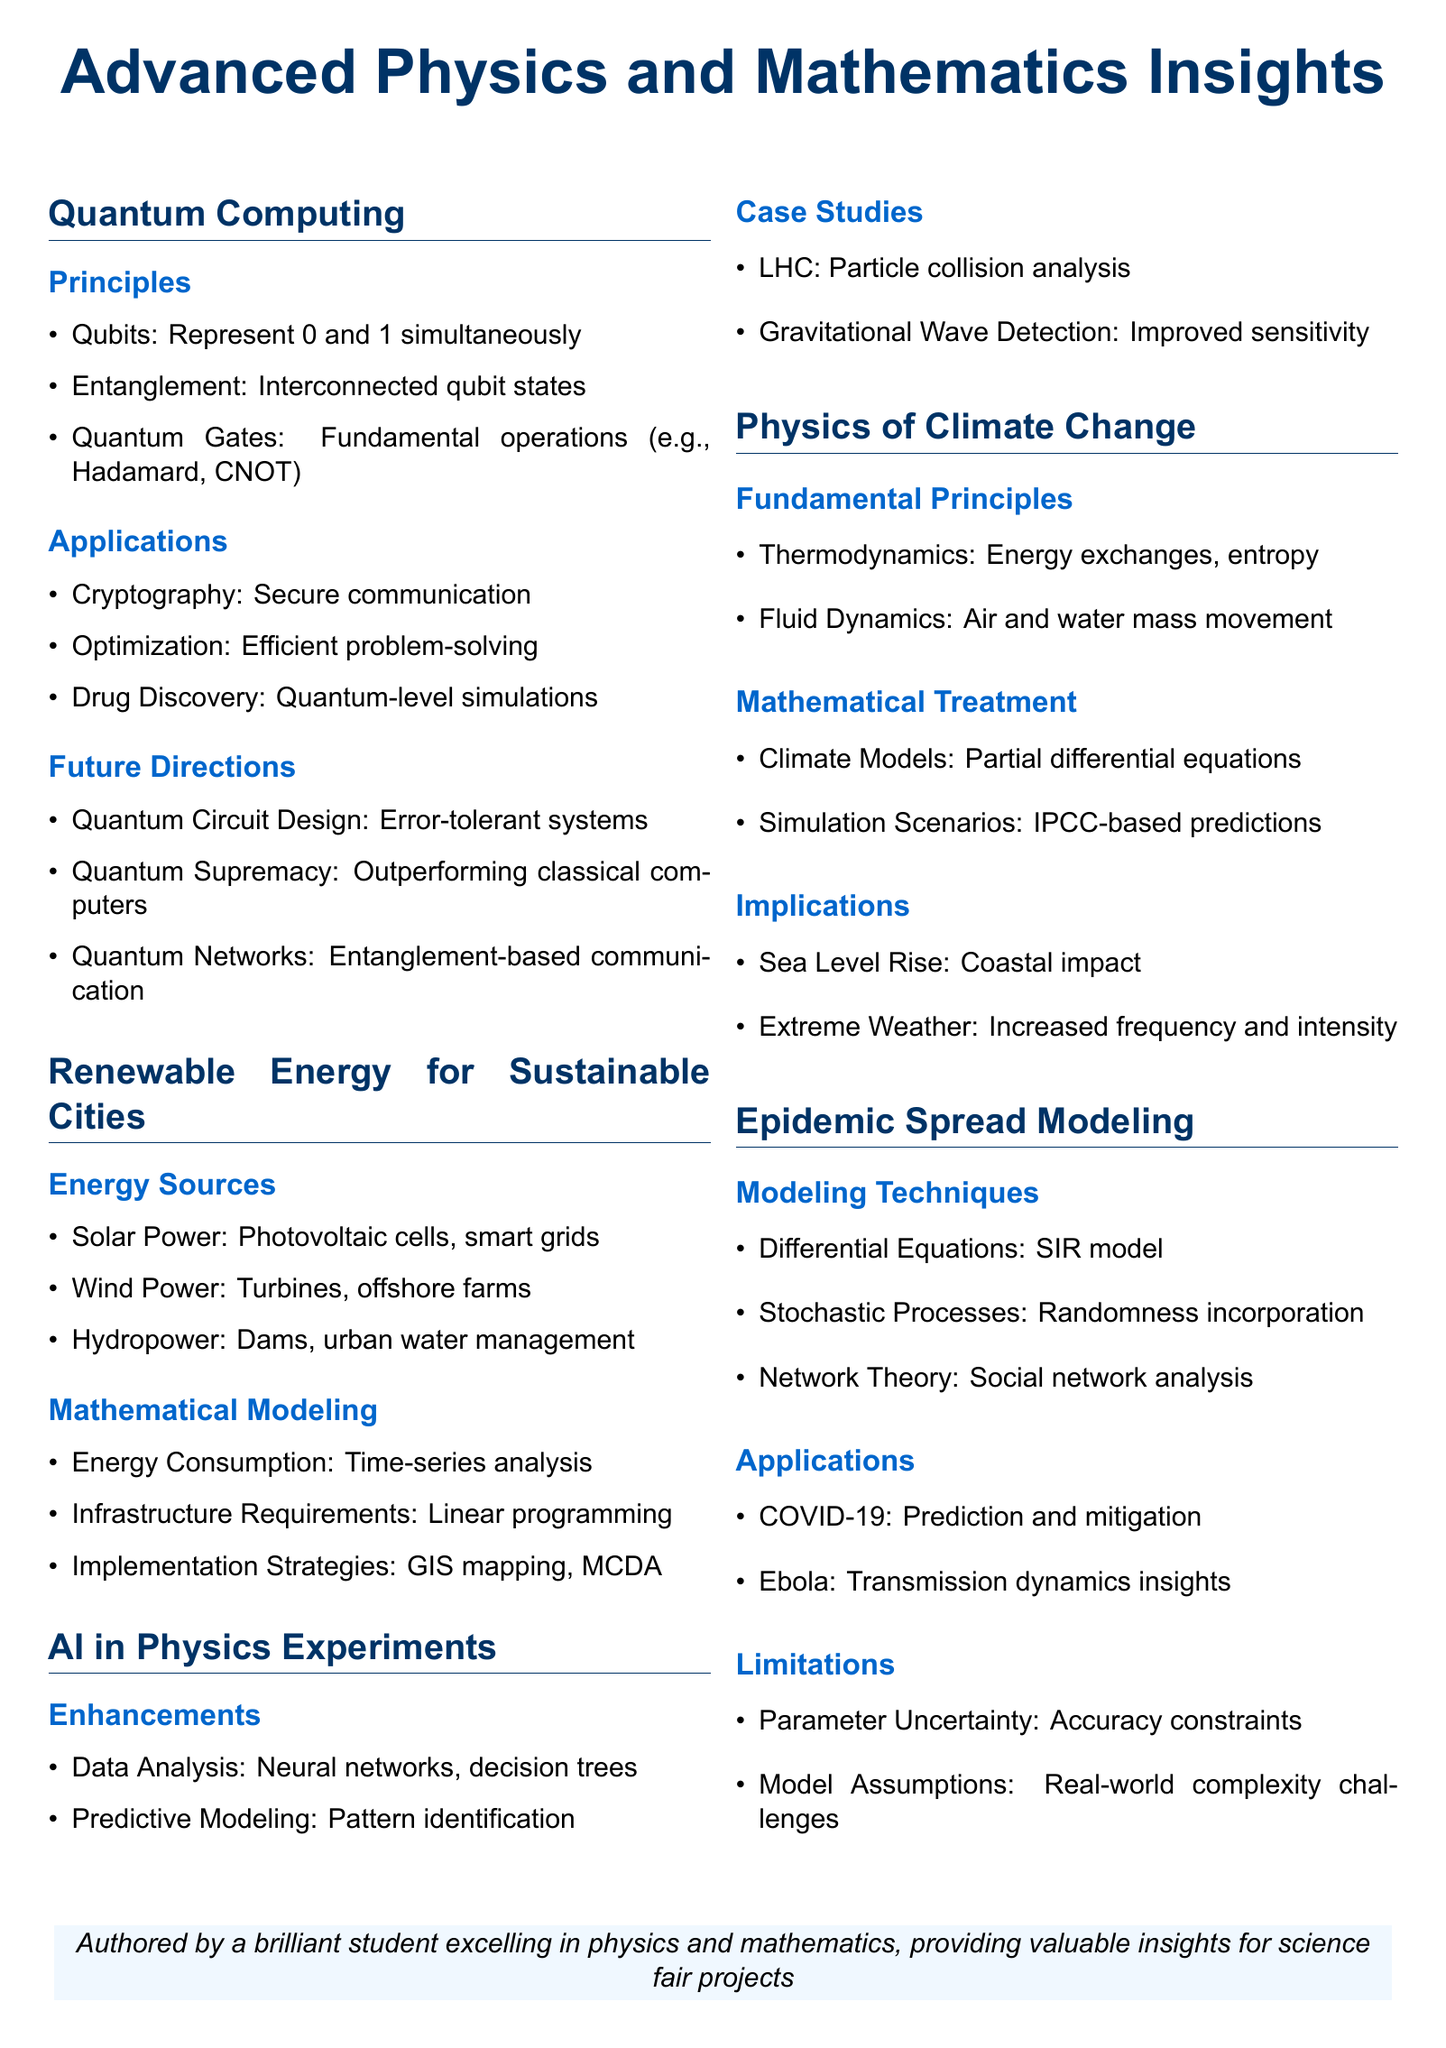what do qubits represent in quantum computing? Qubits represent 0 and 1 simultaneously as stated in the principles section.
Answer: 0 and 1 simultaneously which application of quantum computing is mentioned for drug discovery? The document states that drug discovery utilizes quantum-level simulations as an application.
Answer: Quantum-level simulations what are the three main types of renewable energy sources discussed? The renewable energy section lists solar power, wind power, and hydropower as the main types discussed.
Answer: Solar power, wind power, hydropower which mathematical technique is used for energy consumption analysis? Energy consumption patterns are analyzed using time-series analysis as noted in the mathematical modeling section.
Answer: Time-series analysis what does the SIR model relate to in epidemic spread modeling? The SIR model is a technique used within differential equations for modeling epidemic spread according to the document.
Answer: Differential equations how does AI enhance data analysis in physics experiments? The enhancements for AI involve using neural networks and decision trees for data analysis as explained in the AI section.
Answer: Neural networks, decision trees what is one implication of climate change mentioned in the document? The document lists sea level rise as one of the implications of climate change.
Answer: Sea level rise which stochastic process is mentioned in the context of epidemic spread? The document specifies the incorporation of randomness using stochastic processes in epidemic modeling.
Answer: Stochastic processes what is the focus of the studies in AI integration for physics experiments? Case studies in AI focus on particle collision analysis and improved sensitivity in gravitational wave detection.
Answer: Particle collision analysis, improved sensitivity 